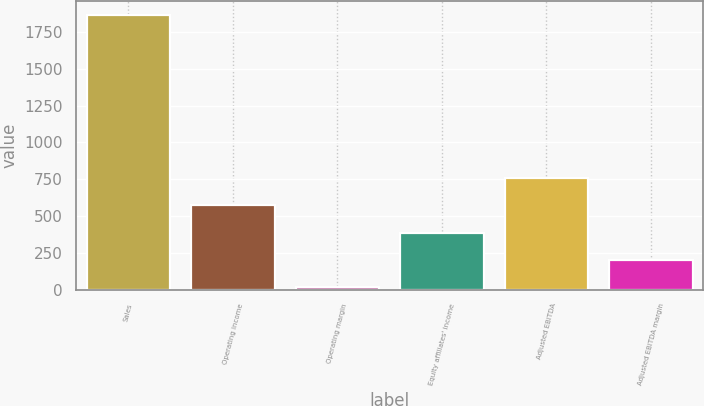Convert chart. <chart><loc_0><loc_0><loc_500><loc_500><bar_chart><fcel>Sales<fcel>Operating income<fcel>Operating margin<fcel>Equity affiliates' income<fcel>Adjusted EBITDA<fcel>Adjusted EBITDA margin<nl><fcel>1866.4<fcel>572.38<fcel>17.8<fcel>387.52<fcel>757.24<fcel>202.66<nl></chart> 